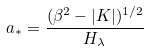<formula> <loc_0><loc_0><loc_500><loc_500>a _ { * } = \frac { ( \beta ^ { 2 } - | K | ) ^ { 1 / 2 } } { H _ { \lambda } }</formula> 